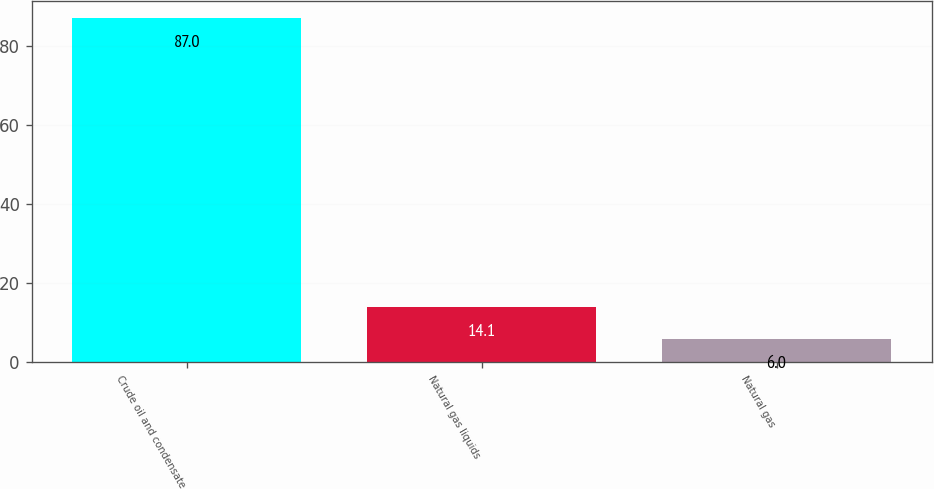Convert chart to OTSL. <chart><loc_0><loc_0><loc_500><loc_500><bar_chart><fcel>Crude oil and condensate<fcel>Natural gas liquids<fcel>Natural gas<nl><fcel>87<fcel>14.1<fcel>6<nl></chart> 